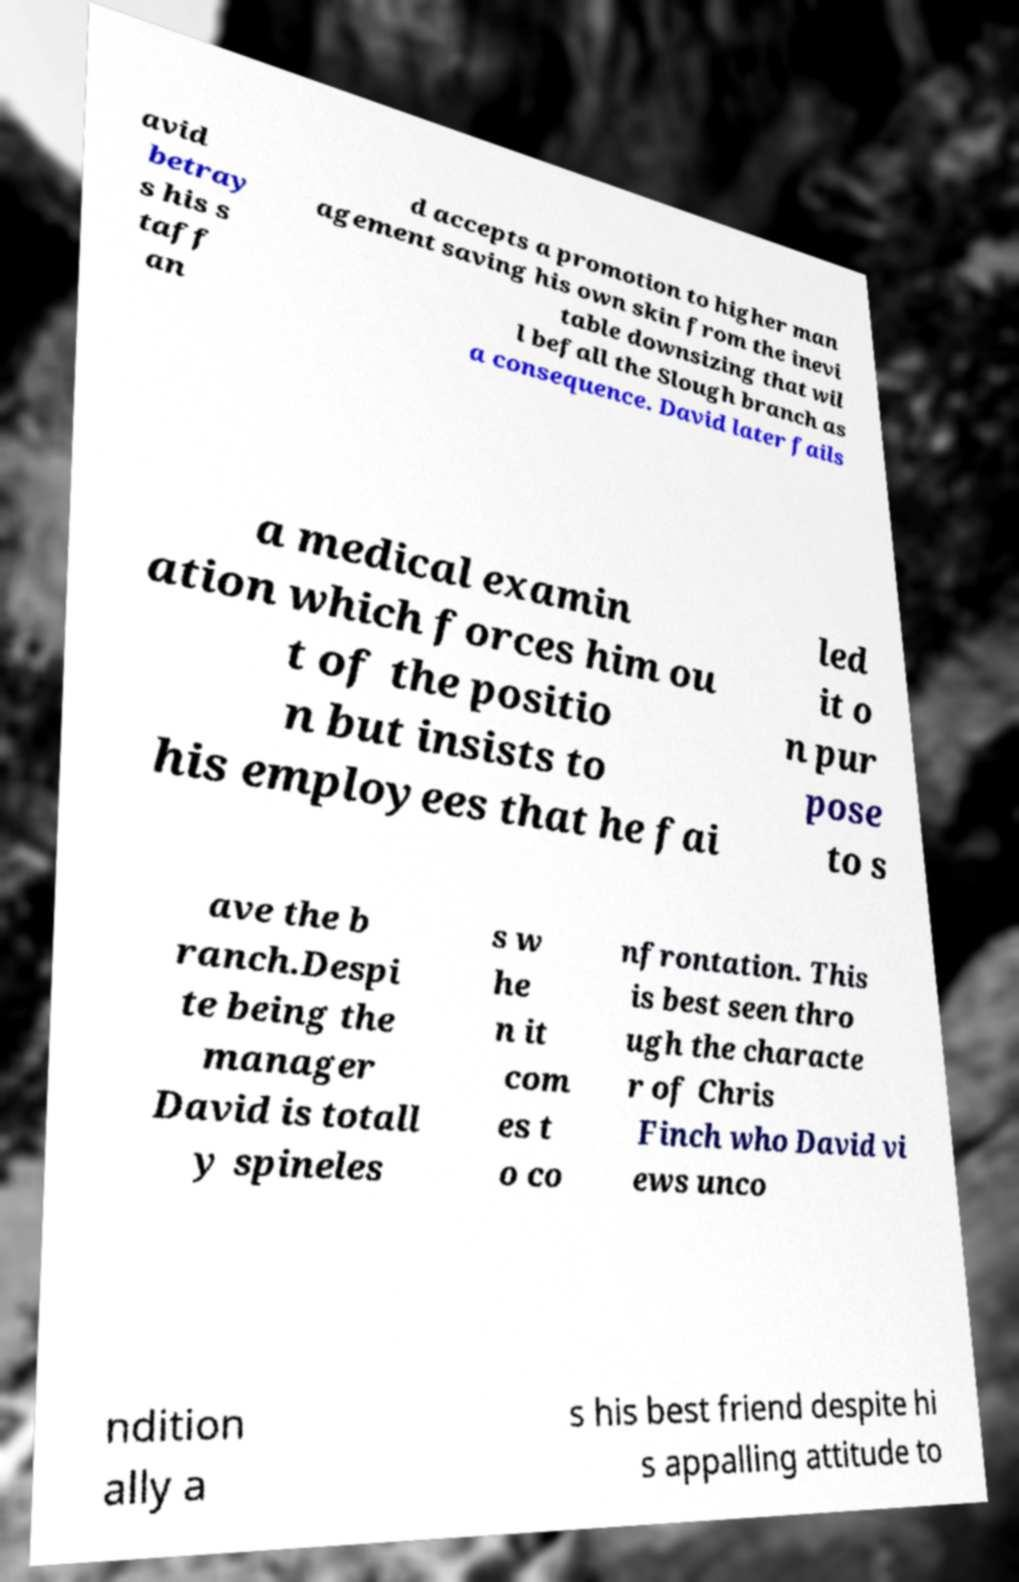There's text embedded in this image that I need extracted. Can you transcribe it verbatim? avid betray s his s taff an d accepts a promotion to higher man agement saving his own skin from the inevi table downsizing that wil l befall the Slough branch as a consequence. David later fails a medical examin ation which forces him ou t of the positio n but insists to his employees that he fai led it o n pur pose to s ave the b ranch.Despi te being the manager David is totall y spineles s w he n it com es t o co nfrontation. This is best seen thro ugh the characte r of Chris Finch who David vi ews unco ndition ally a s his best friend despite hi s appalling attitude to 